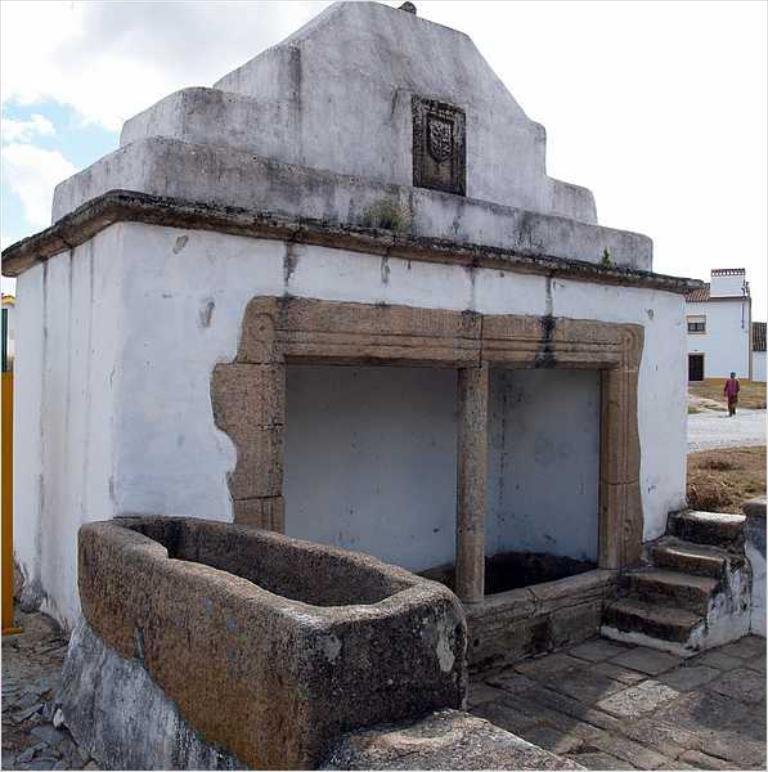What type of structures can be seen in the image? There are buildings in the image. What is the person in the image doing? There is a person walking on the road in the image. What can be seen in the background of the image? There is a sky visible in the background of the image. How many baskets can be seen in the person's hand in the image? There are no baskets visible in the image, nor is there a person holding anything. 